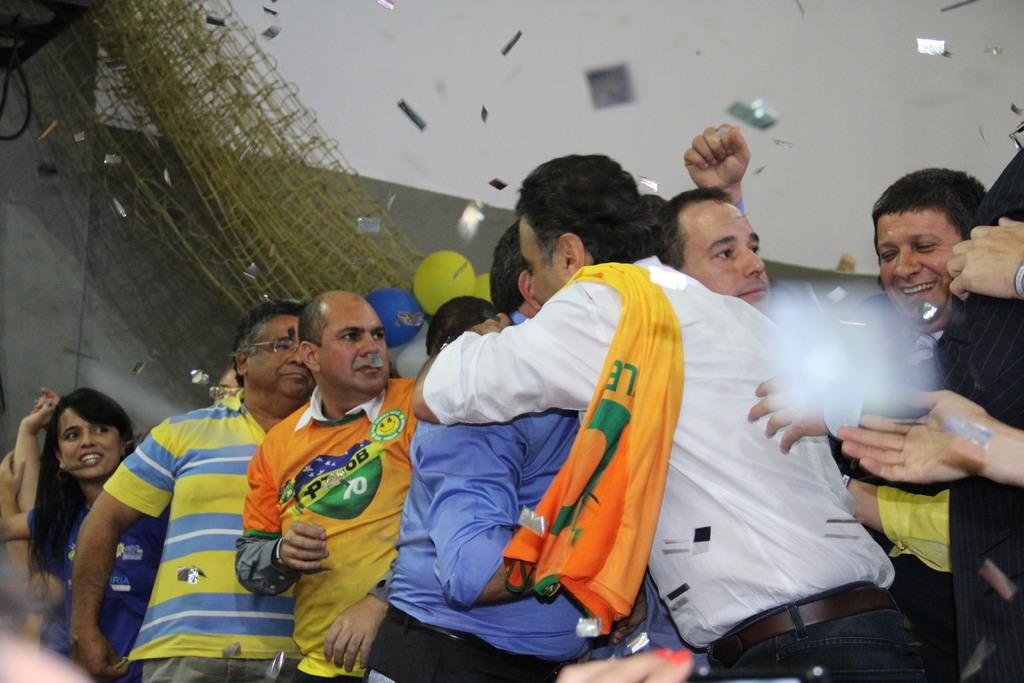How many people are in the image? There is a group of people in the image. What are the people wearing? The people are wearing different color dresses. What can be seen in the background of the image? There are colorful balloons, a net, and a wall in the background. How many beds are visible in the image? There are no beds present in the image. What type of shade is being provided by the balloons in the image? The balloons in the image are not providing any shade, as they are in the background and not directly above any people or objects. 